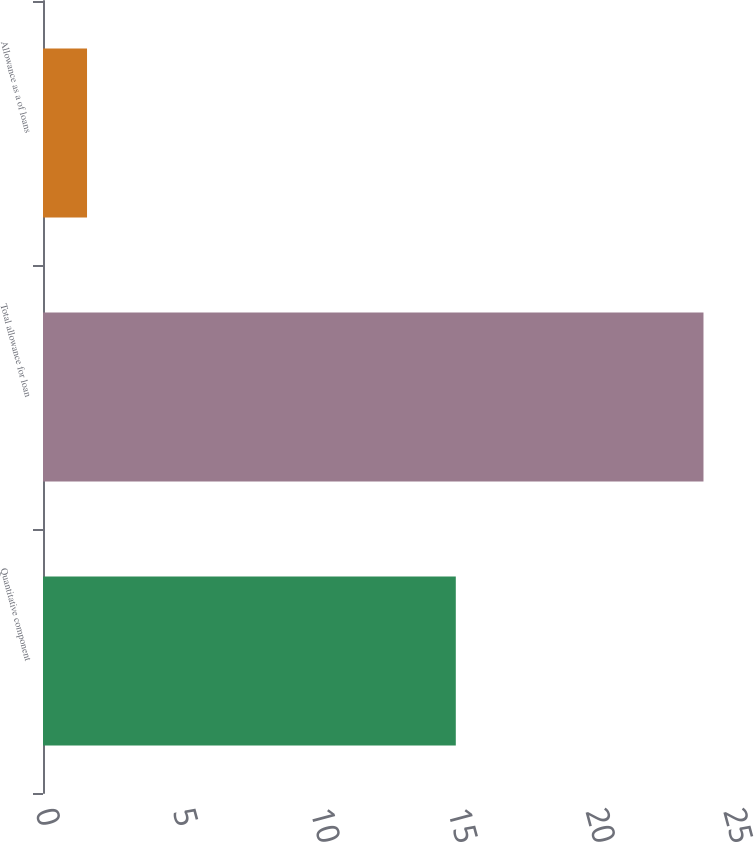<chart> <loc_0><loc_0><loc_500><loc_500><bar_chart><fcel>Quantitative component<fcel>Total allowance for loan<fcel>Allowance as a of loans<nl><fcel>15<fcel>24<fcel>1.6<nl></chart> 